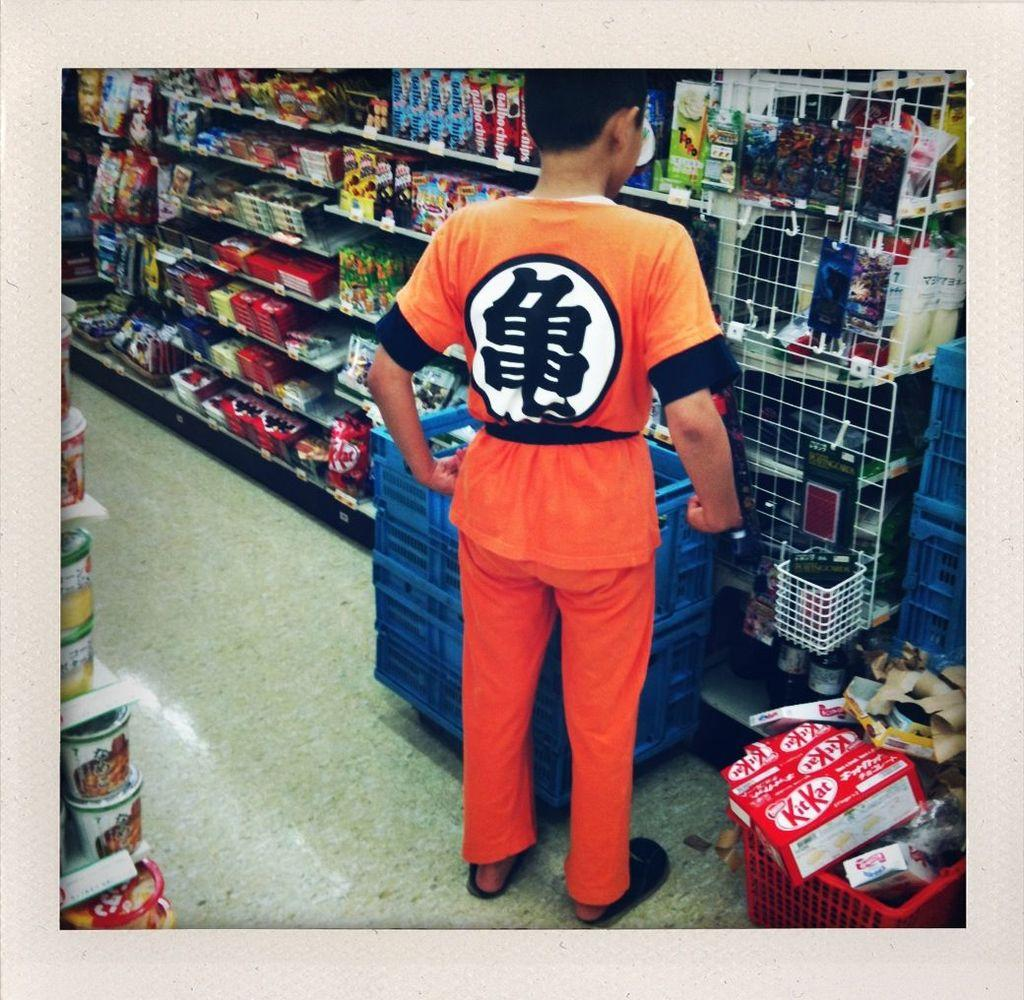<image>
Share a concise interpretation of the image provided. The man in orange has two boxes of Kit Kat in his cart. 